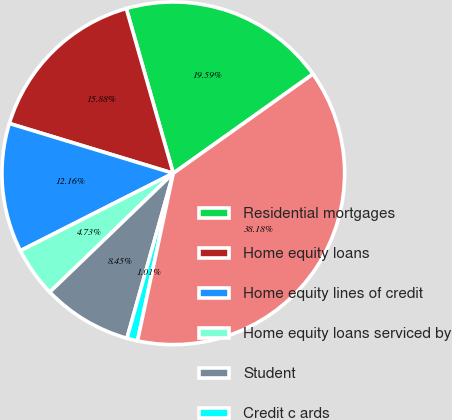<chart> <loc_0><loc_0><loc_500><loc_500><pie_chart><fcel>Residential mortgages<fcel>Home equity loans<fcel>Home equity lines of credit<fcel>Home equity loans serviced by<fcel>Student<fcel>Credit c ards<fcel>Total<nl><fcel>19.59%<fcel>15.88%<fcel>12.16%<fcel>4.73%<fcel>8.45%<fcel>1.01%<fcel>38.18%<nl></chart> 